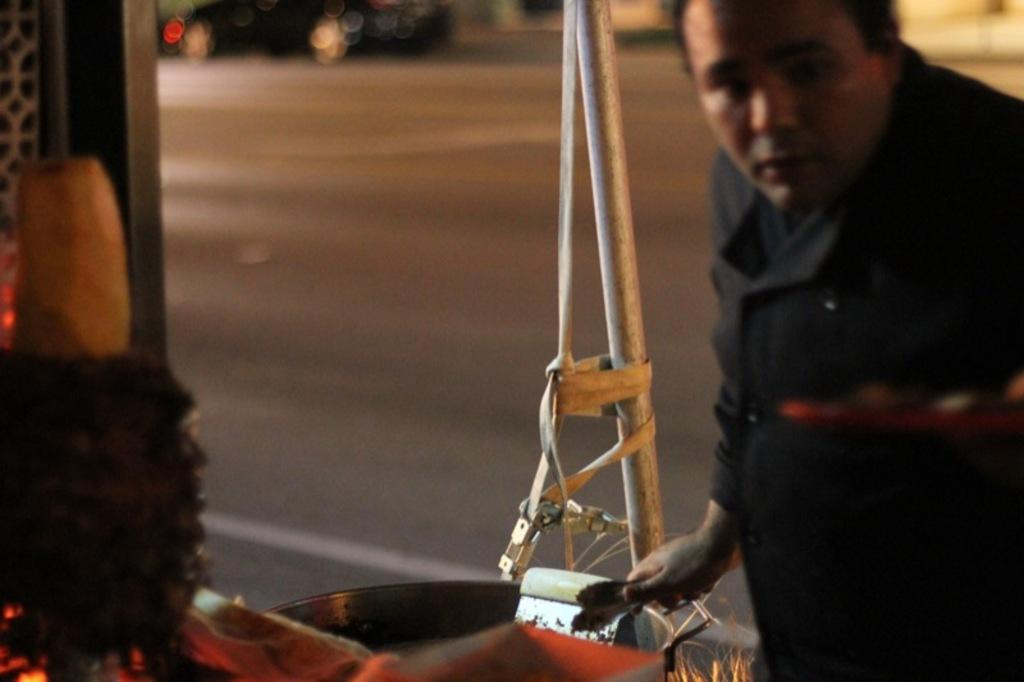Who or what can be seen in the image? There is a person in the image. What is the person doing in the image? The person is holding an object. Can you describe the object placed on the table in the image? There is an object placed on a table in the image. What can be seen in the distance in the image? There is a road visible in the background of the image. How does the person in the image shake hands with the expert? There is no expert present in the image, and the person is not shaking hands. 